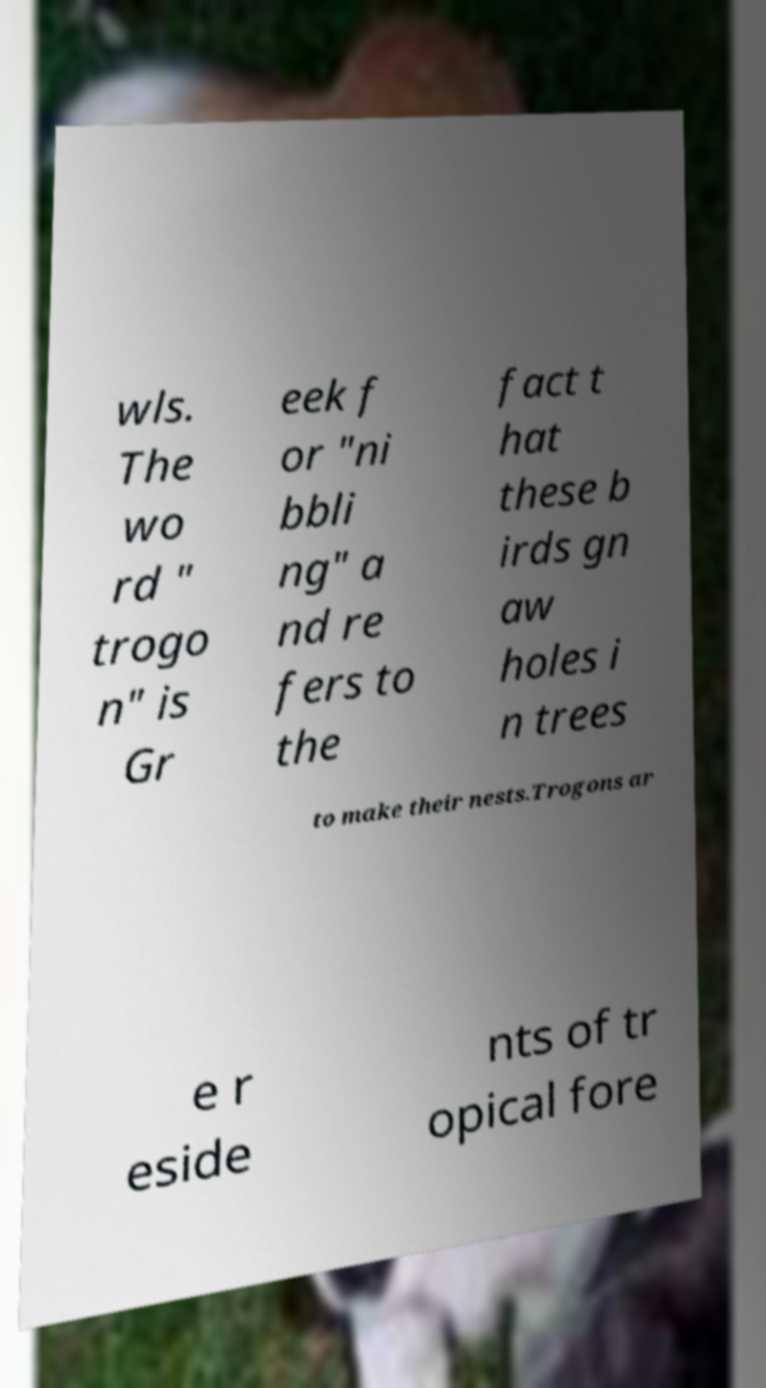I need the written content from this picture converted into text. Can you do that? wls. The wo rd " trogo n" is Gr eek f or "ni bbli ng" a nd re fers to the fact t hat these b irds gn aw holes i n trees to make their nests.Trogons ar e r eside nts of tr opical fore 